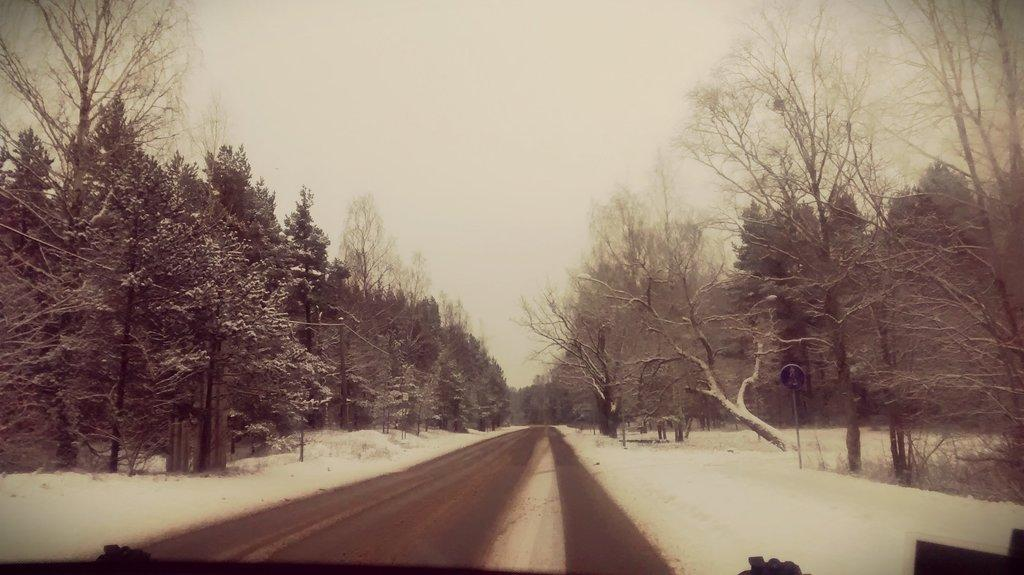What is the main feature in the middle of the image? There is a road in the middle of the image. What can be seen on both sides of the road? There are trees on either side of the road. What is the weather condition in the image? There is snow in the image, indicating a cold or wintery condition. What is visible at the top of the image? The sky is visible at the top of the image. Can you see any water flowing along the road in the image? There is no water flowing along the road in the image; it is covered in snow. What type of tool is being used to dig in the snow in the image? There is no tool being used to dig in the snow in the image; the image only shows a road, trees, snow, and the sky. 